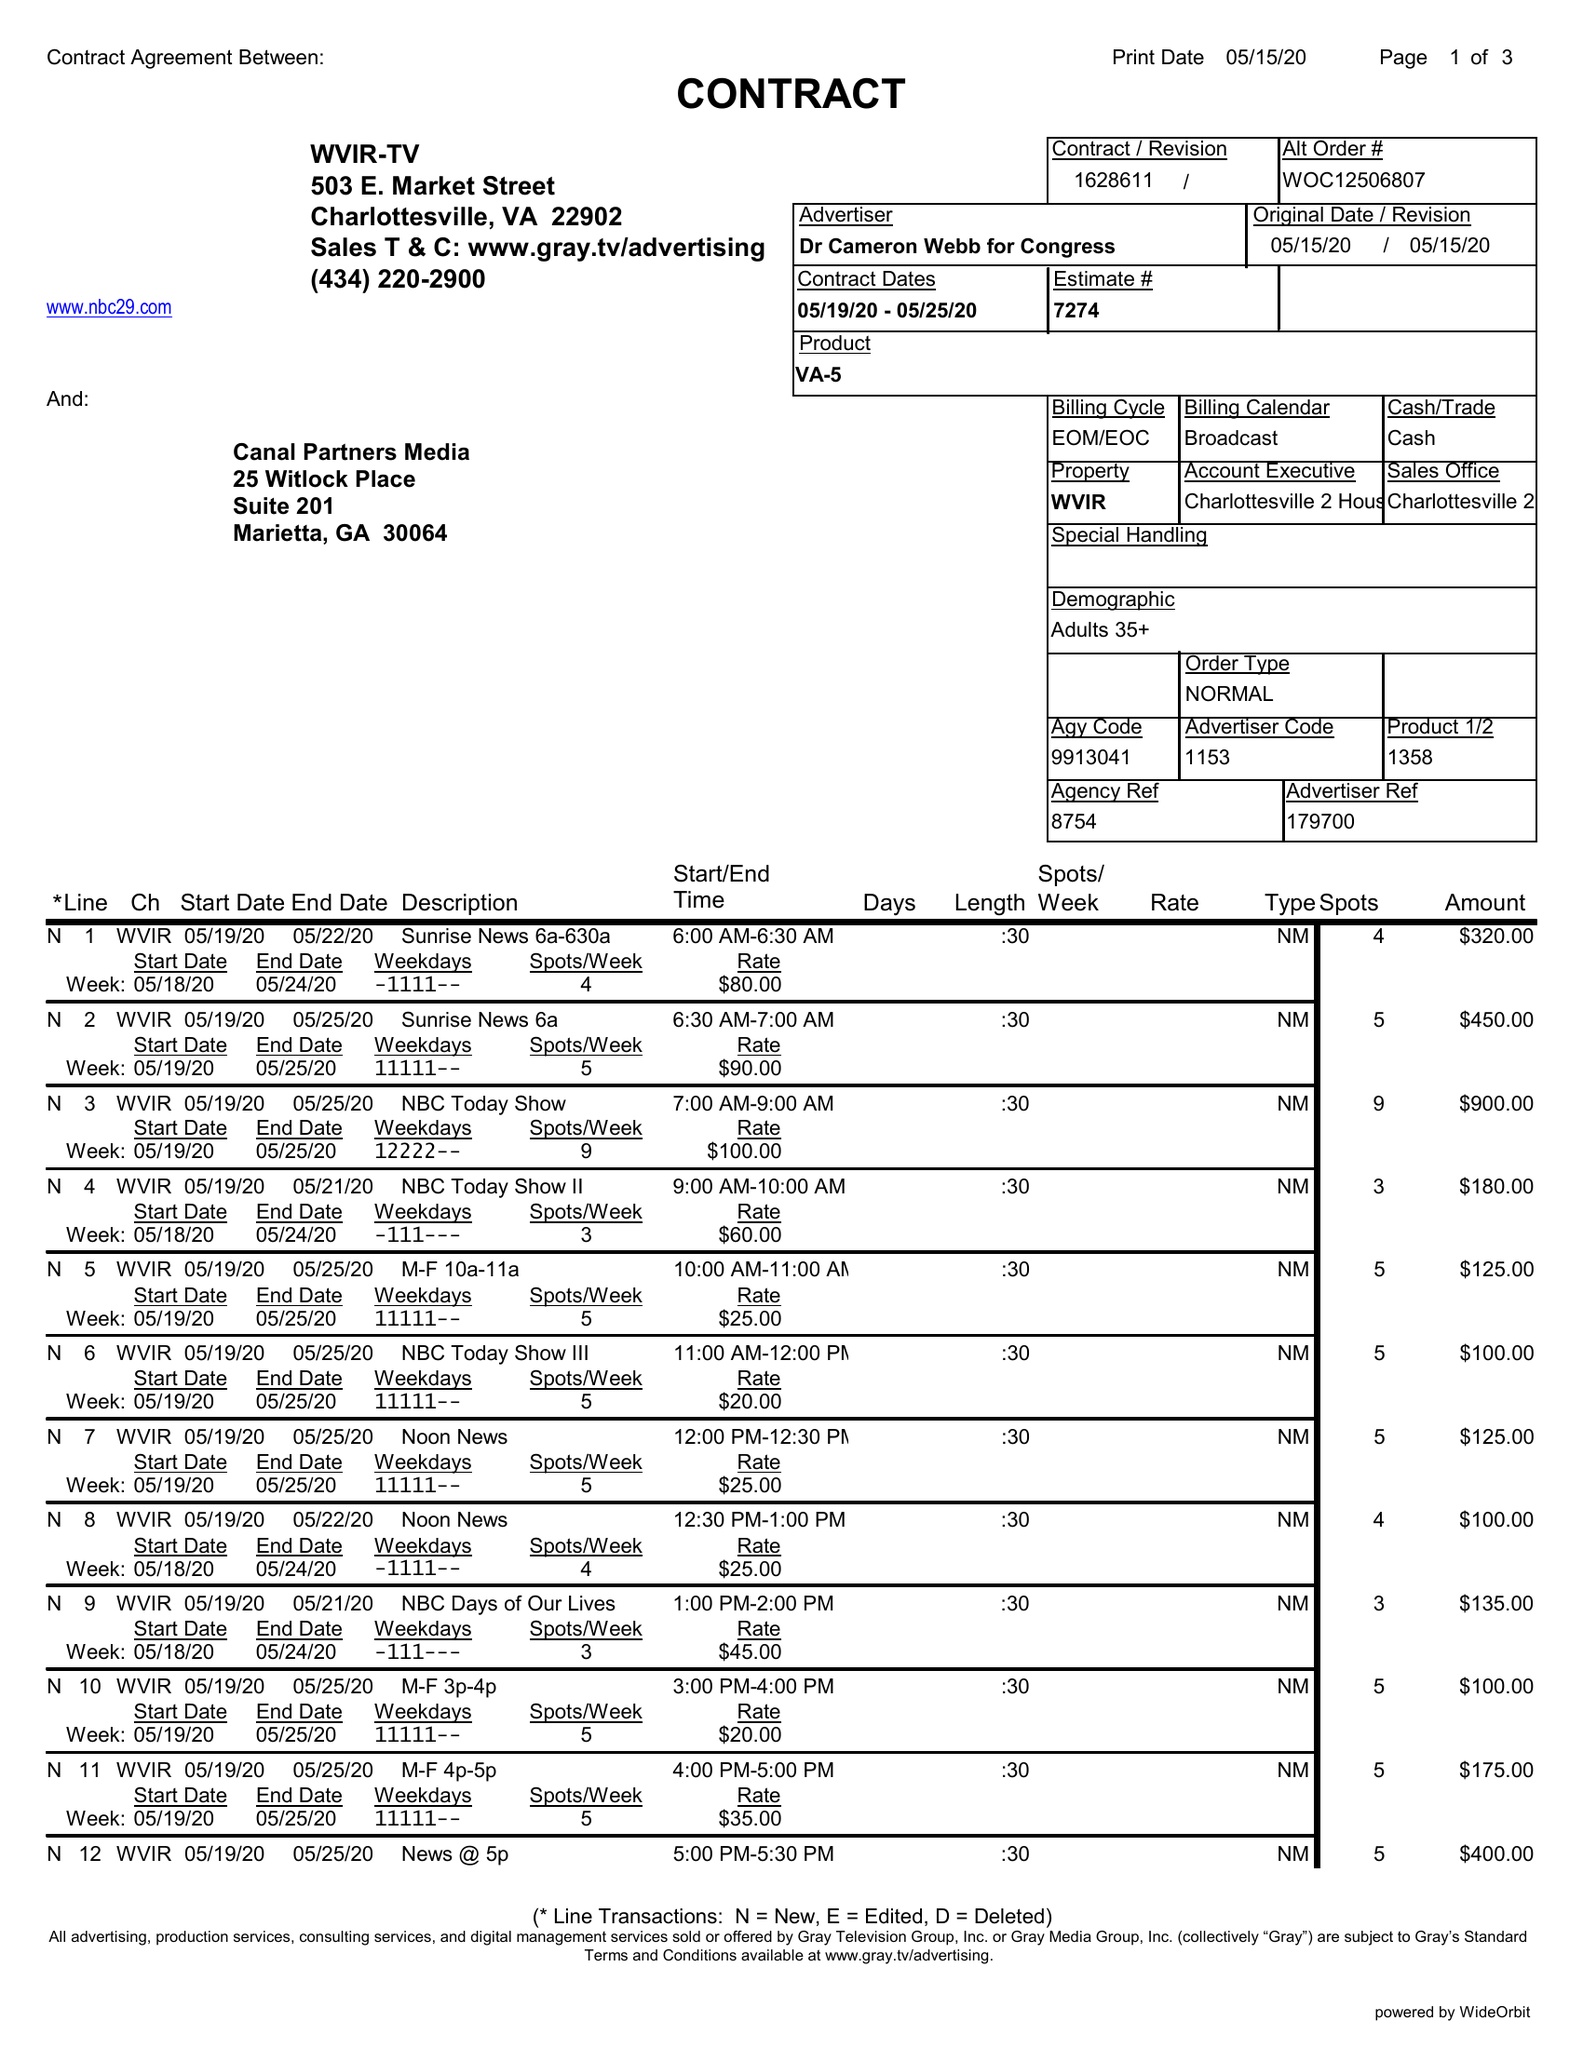What is the value for the flight_to?
Answer the question using a single word or phrase. 05/25/20 